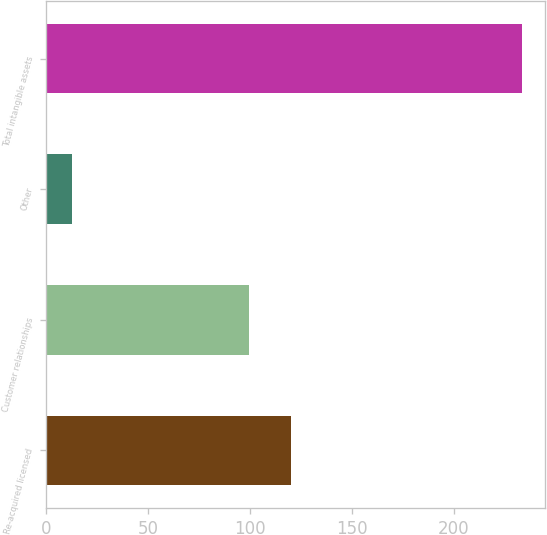<chart> <loc_0><loc_0><loc_500><loc_500><bar_chart><fcel>Re-acquired licensed<fcel>Customer relationships<fcel>Other<fcel>Total intangible assets<nl><fcel>119.94<fcel>99.2<fcel>12.4<fcel>233.24<nl></chart> 